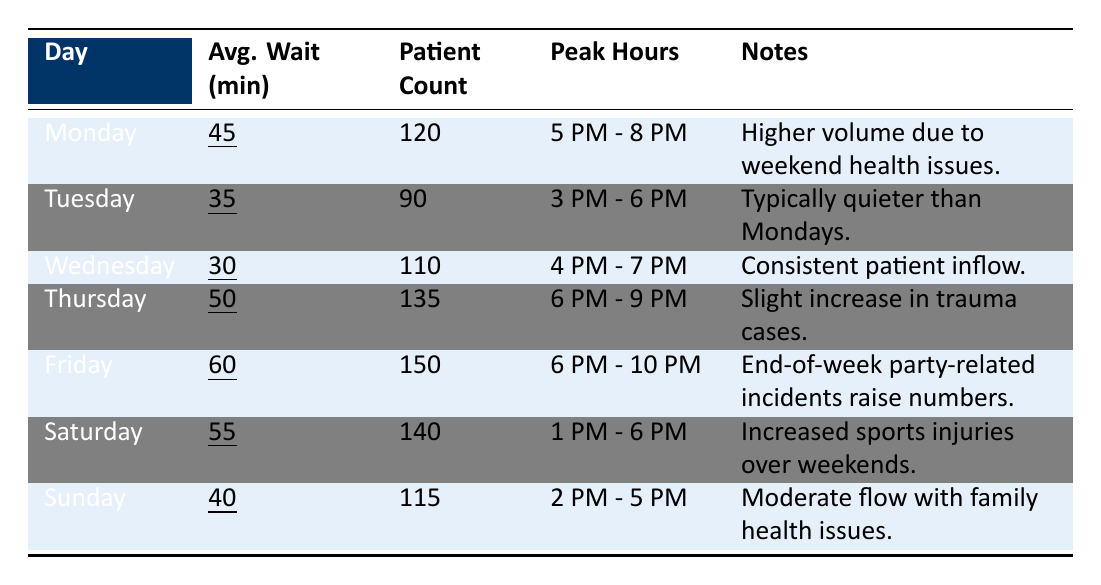What is the average wait time on Friday? The table shows that the average wait time on Friday is underlined, which is 60 minutes.
Answer: 60 minutes What are the peak hours for patient visits on Wednesday? The peak hours listed for Wednesday in the table is 4 PM - 7 PM.
Answer: 4 PM - 7 PM Which day has the highest patient count? By comparing the patient counts listed, Friday has the highest count of 150 patients.
Answer: Friday On which day is the average wait time lowest? The lowest average wait time can be found by comparing all weekdays; Wednesday has the lowest at 30 minutes.
Answer: Wednesday Is Tuesday quieter than Monday in terms of patient count? Yes, the patient count for Tuesday is 90, which is lower than Monday's count of 120.
Answer: Yes What is the total patient count for the weekend (Saturday and Sunday)? The total patient count can be calculated as Saturday's 140 plus Sunday's 115, which equals 255 patients.
Answer: 255 patients What day has the longest peak hours? By comparing the peak hours listed, Friday has the longest duration of 4 hours (6 PM - 10 PM).
Answer: Friday Is the average wait time on Thursday higher than on Sunday? Yes, Thursday has an average wait time of 50 minutes, while Sunday has 40 minutes, indicating Thursday is higher.
Answer: Yes What is the average wait time across all days of the week? To find the average, sum the values (45 + 35 + 30 + 50 + 60 + 55 + 40 = 315) and divide by 7 days, which results in an average wait time of 45 minutes.
Answer: 45 minutes What is the difference in average wait time between the busiest and the quietest day? The busiest day is Friday (60 minutes) and the quietest is Wednesday (30 minutes); the difference is 60 - 30 = 30 minutes.
Answer: 30 minutes 